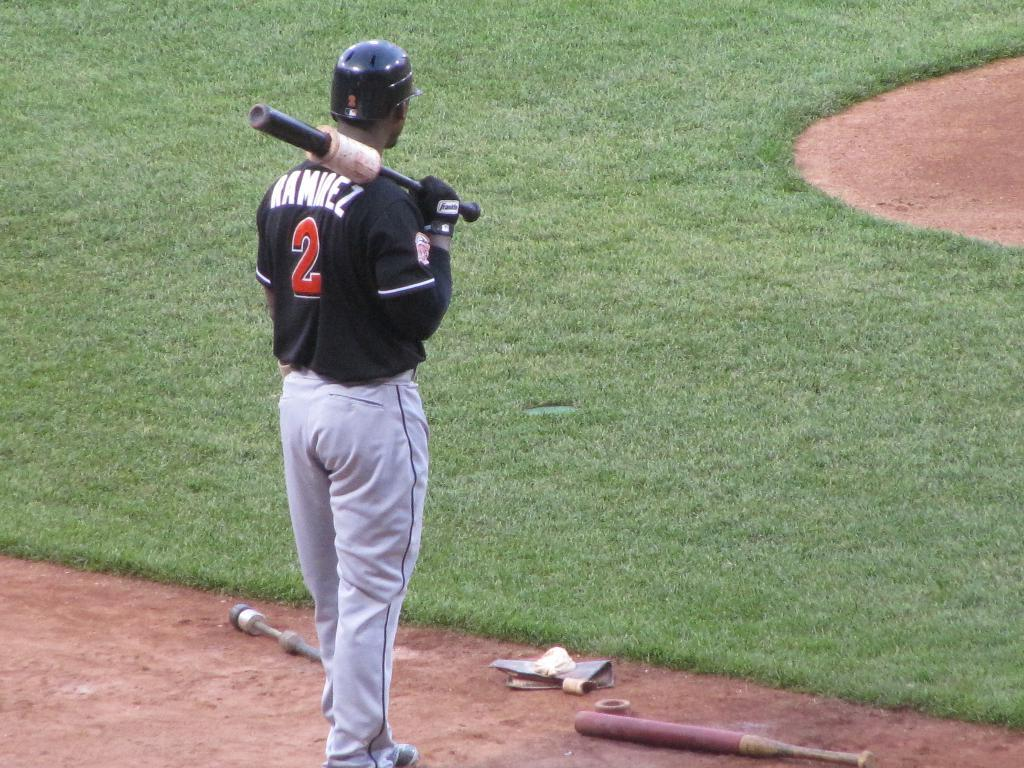What is the person in the image wearing on their head and hands? The person is wearing a helmet and gloves. What object is the person holding in the image? The person is holding a bat. What can be seen on the ground in the image? There is a bat on the ground, as well as other things. What type of surface is visible in the image? There is a grass lawn in the image. What type of joke is being told by the cloud in the image? There is no cloud present in the image, and therefore no joke can be attributed to it. 